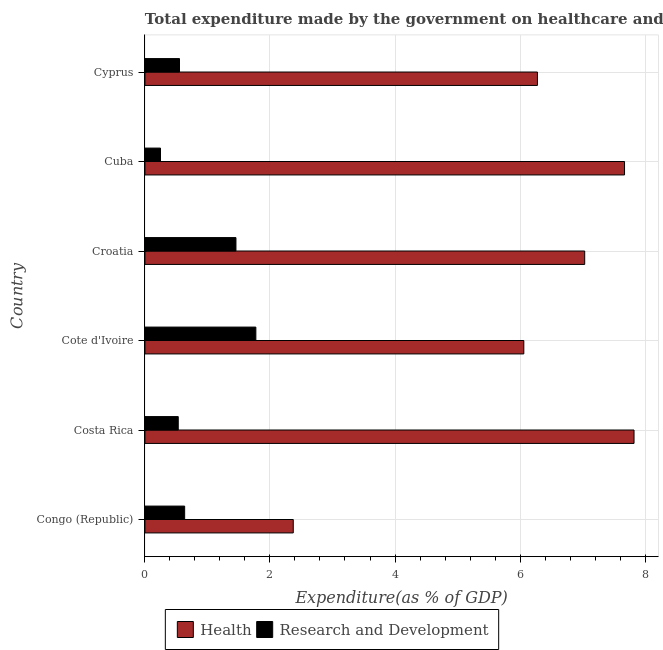How many groups of bars are there?
Give a very brief answer. 6. Are the number of bars per tick equal to the number of legend labels?
Ensure brevity in your answer.  Yes. Are the number of bars on each tick of the Y-axis equal?
Make the answer very short. Yes. How many bars are there on the 6th tick from the top?
Your answer should be very brief. 2. How many bars are there on the 1st tick from the bottom?
Keep it short and to the point. 2. What is the label of the 2nd group of bars from the top?
Offer a terse response. Cuba. What is the expenditure in r&d in Cuba?
Provide a short and direct response. 0.25. Across all countries, what is the maximum expenditure in healthcare?
Ensure brevity in your answer.  7.82. Across all countries, what is the minimum expenditure in healthcare?
Make the answer very short. 2.37. In which country was the expenditure in healthcare maximum?
Your answer should be very brief. Costa Rica. In which country was the expenditure in r&d minimum?
Provide a succinct answer. Cuba. What is the total expenditure in r&d in the graph?
Your answer should be very brief. 5.2. What is the difference between the expenditure in r&d in Cote d'Ivoire and that in Cuba?
Ensure brevity in your answer.  1.52. What is the difference between the expenditure in r&d in Costa Rica and the expenditure in healthcare in Congo (Republic)?
Keep it short and to the point. -1.84. What is the average expenditure in r&d per country?
Provide a succinct answer. 0.87. What is the difference between the expenditure in r&d and expenditure in healthcare in Croatia?
Make the answer very short. -5.58. In how many countries, is the expenditure in healthcare greater than 5.6 %?
Provide a short and direct response. 5. What is the ratio of the expenditure in r&d in Costa Rica to that in Cuba?
Offer a terse response. 2.14. Is the expenditure in healthcare in Cuba less than that in Cyprus?
Provide a succinct answer. No. Is the difference between the expenditure in r&d in Cote d'Ivoire and Cyprus greater than the difference between the expenditure in healthcare in Cote d'Ivoire and Cyprus?
Your answer should be compact. Yes. What is the difference between the highest and the second highest expenditure in healthcare?
Offer a very short reply. 0.15. What is the difference between the highest and the lowest expenditure in healthcare?
Provide a succinct answer. 5.45. In how many countries, is the expenditure in r&d greater than the average expenditure in r&d taken over all countries?
Make the answer very short. 2. What does the 2nd bar from the top in Cote d'Ivoire represents?
Your answer should be very brief. Health. What does the 1st bar from the bottom in Cote d'Ivoire represents?
Your answer should be compact. Health. What is the difference between two consecutive major ticks on the X-axis?
Ensure brevity in your answer.  2. Does the graph contain any zero values?
Keep it short and to the point. No. How many legend labels are there?
Give a very brief answer. 2. What is the title of the graph?
Your answer should be very brief. Total expenditure made by the government on healthcare and R&D projects in 2006. What is the label or title of the X-axis?
Make the answer very short. Expenditure(as % of GDP). What is the label or title of the Y-axis?
Offer a very short reply. Country. What is the Expenditure(as % of GDP) of Health in Congo (Republic)?
Keep it short and to the point. 2.37. What is the Expenditure(as % of GDP) in Research and Development in Congo (Republic)?
Your answer should be very brief. 0.64. What is the Expenditure(as % of GDP) in Health in Costa Rica?
Provide a succinct answer. 7.82. What is the Expenditure(as % of GDP) in Research and Development in Costa Rica?
Ensure brevity in your answer.  0.53. What is the Expenditure(as % of GDP) in Health in Cote d'Ivoire?
Your response must be concise. 6.06. What is the Expenditure(as % of GDP) of Research and Development in Cote d'Ivoire?
Provide a short and direct response. 1.77. What is the Expenditure(as % of GDP) of Health in Croatia?
Keep it short and to the point. 7.03. What is the Expenditure(as % of GDP) of Research and Development in Croatia?
Keep it short and to the point. 1.46. What is the Expenditure(as % of GDP) of Health in Cuba?
Your response must be concise. 7.67. What is the Expenditure(as % of GDP) in Research and Development in Cuba?
Your answer should be very brief. 0.25. What is the Expenditure(as % of GDP) of Health in Cyprus?
Provide a succinct answer. 6.28. What is the Expenditure(as % of GDP) in Research and Development in Cyprus?
Give a very brief answer. 0.55. Across all countries, what is the maximum Expenditure(as % of GDP) of Health?
Keep it short and to the point. 7.82. Across all countries, what is the maximum Expenditure(as % of GDP) in Research and Development?
Give a very brief answer. 1.77. Across all countries, what is the minimum Expenditure(as % of GDP) of Health?
Make the answer very short. 2.37. Across all countries, what is the minimum Expenditure(as % of GDP) of Research and Development?
Give a very brief answer. 0.25. What is the total Expenditure(as % of GDP) in Health in the graph?
Give a very brief answer. 37.24. What is the total Expenditure(as % of GDP) in Research and Development in the graph?
Provide a short and direct response. 5.2. What is the difference between the Expenditure(as % of GDP) in Health in Congo (Republic) and that in Costa Rica?
Make the answer very short. -5.45. What is the difference between the Expenditure(as % of GDP) of Research and Development in Congo (Republic) and that in Costa Rica?
Offer a very short reply. 0.1. What is the difference between the Expenditure(as % of GDP) in Health in Congo (Republic) and that in Cote d'Ivoire?
Provide a short and direct response. -3.69. What is the difference between the Expenditure(as % of GDP) of Research and Development in Congo (Republic) and that in Cote d'Ivoire?
Provide a succinct answer. -1.14. What is the difference between the Expenditure(as % of GDP) in Health in Congo (Republic) and that in Croatia?
Ensure brevity in your answer.  -4.66. What is the difference between the Expenditure(as % of GDP) of Research and Development in Congo (Republic) and that in Croatia?
Your answer should be very brief. -0.82. What is the difference between the Expenditure(as % of GDP) in Health in Congo (Republic) and that in Cuba?
Make the answer very short. -5.3. What is the difference between the Expenditure(as % of GDP) of Research and Development in Congo (Republic) and that in Cuba?
Offer a terse response. 0.39. What is the difference between the Expenditure(as % of GDP) of Health in Congo (Republic) and that in Cyprus?
Provide a succinct answer. -3.91. What is the difference between the Expenditure(as % of GDP) in Research and Development in Congo (Republic) and that in Cyprus?
Provide a succinct answer. 0.08. What is the difference between the Expenditure(as % of GDP) of Health in Costa Rica and that in Cote d'Ivoire?
Provide a succinct answer. 1.76. What is the difference between the Expenditure(as % of GDP) of Research and Development in Costa Rica and that in Cote d'Ivoire?
Give a very brief answer. -1.24. What is the difference between the Expenditure(as % of GDP) in Health in Costa Rica and that in Croatia?
Ensure brevity in your answer.  0.79. What is the difference between the Expenditure(as % of GDP) in Research and Development in Costa Rica and that in Croatia?
Ensure brevity in your answer.  -0.92. What is the difference between the Expenditure(as % of GDP) in Health in Costa Rica and that in Cuba?
Make the answer very short. 0.15. What is the difference between the Expenditure(as % of GDP) of Research and Development in Costa Rica and that in Cuba?
Make the answer very short. 0.28. What is the difference between the Expenditure(as % of GDP) of Health in Costa Rica and that in Cyprus?
Provide a succinct answer. 1.55. What is the difference between the Expenditure(as % of GDP) of Research and Development in Costa Rica and that in Cyprus?
Ensure brevity in your answer.  -0.02. What is the difference between the Expenditure(as % of GDP) of Health in Cote d'Ivoire and that in Croatia?
Offer a very short reply. -0.97. What is the difference between the Expenditure(as % of GDP) in Research and Development in Cote d'Ivoire and that in Croatia?
Your answer should be compact. 0.32. What is the difference between the Expenditure(as % of GDP) in Health in Cote d'Ivoire and that in Cuba?
Your answer should be very brief. -1.61. What is the difference between the Expenditure(as % of GDP) of Research and Development in Cote d'Ivoire and that in Cuba?
Keep it short and to the point. 1.53. What is the difference between the Expenditure(as % of GDP) of Health in Cote d'Ivoire and that in Cyprus?
Your response must be concise. -0.22. What is the difference between the Expenditure(as % of GDP) of Research and Development in Cote d'Ivoire and that in Cyprus?
Your answer should be very brief. 1.22. What is the difference between the Expenditure(as % of GDP) in Health in Croatia and that in Cuba?
Offer a very short reply. -0.64. What is the difference between the Expenditure(as % of GDP) in Research and Development in Croatia and that in Cuba?
Provide a short and direct response. 1.21. What is the difference between the Expenditure(as % of GDP) in Health in Croatia and that in Cyprus?
Make the answer very short. 0.76. What is the difference between the Expenditure(as % of GDP) in Research and Development in Croatia and that in Cyprus?
Make the answer very short. 0.9. What is the difference between the Expenditure(as % of GDP) of Health in Cuba and that in Cyprus?
Your response must be concise. 1.39. What is the difference between the Expenditure(as % of GDP) in Research and Development in Cuba and that in Cyprus?
Give a very brief answer. -0.3. What is the difference between the Expenditure(as % of GDP) in Health in Congo (Republic) and the Expenditure(as % of GDP) in Research and Development in Costa Rica?
Keep it short and to the point. 1.84. What is the difference between the Expenditure(as % of GDP) of Health in Congo (Republic) and the Expenditure(as % of GDP) of Research and Development in Cote d'Ivoire?
Offer a terse response. 0.6. What is the difference between the Expenditure(as % of GDP) of Health in Congo (Republic) and the Expenditure(as % of GDP) of Research and Development in Cuba?
Keep it short and to the point. 2.12. What is the difference between the Expenditure(as % of GDP) of Health in Congo (Republic) and the Expenditure(as % of GDP) of Research and Development in Cyprus?
Your response must be concise. 1.82. What is the difference between the Expenditure(as % of GDP) of Health in Costa Rica and the Expenditure(as % of GDP) of Research and Development in Cote d'Ivoire?
Your response must be concise. 6.05. What is the difference between the Expenditure(as % of GDP) in Health in Costa Rica and the Expenditure(as % of GDP) in Research and Development in Croatia?
Your answer should be very brief. 6.37. What is the difference between the Expenditure(as % of GDP) in Health in Costa Rica and the Expenditure(as % of GDP) in Research and Development in Cuba?
Give a very brief answer. 7.57. What is the difference between the Expenditure(as % of GDP) in Health in Costa Rica and the Expenditure(as % of GDP) in Research and Development in Cyprus?
Your answer should be compact. 7.27. What is the difference between the Expenditure(as % of GDP) in Health in Cote d'Ivoire and the Expenditure(as % of GDP) in Research and Development in Croatia?
Offer a terse response. 4.6. What is the difference between the Expenditure(as % of GDP) in Health in Cote d'Ivoire and the Expenditure(as % of GDP) in Research and Development in Cuba?
Your answer should be very brief. 5.81. What is the difference between the Expenditure(as % of GDP) of Health in Cote d'Ivoire and the Expenditure(as % of GDP) of Research and Development in Cyprus?
Offer a very short reply. 5.51. What is the difference between the Expenditure(as % of GDP) of Health in Croatia and the Expenditure(as % of GDP) of Research and Development in Cuba?
Ensure brevity in your answer.  6.79. What is the difference between the Expenditure(as % of GDP) in Health in Croatia and the Expenditure(as % of GDP) in Research and Development in Cyprus?
Keep it short and to the point. 6.48. What is the difference between the Expenditure(as % of GDP) of Health in Cuba and the Expenditure(as % of GDP) of Research and Development in Cyprus?
Offer a terse response. 7.12. What is the average Expenditure(as % of GDP) in Health per country?
Provide a short and direct response. 6.21. What is the average Expenditure(as % of GDP) in Research and Development per country?
Keep it short and to the point. 0.87. What is the difference between the Expenditure(as % of GDP) in Health and Expenditure(as % of GDP) in Research and Development in Congo (Republic)?
Offer a terse response. 1.74. What is the difference between the Expenditure(as % of GDP) of Health and Expenditure(as % of GDP) of Research and Development in Costa Rica?
Offer a very short reply. 7.29. What is the difference between the Expenditure(as % of GDP) of Health and Expenditure(as % of GDP) of Research and Development in Cote d'Ivoire?
Your answer should be compact. 4.29. What is the difference between the Expenditure(as % of GDP) of Health and Expenditure(as % of GDP) of Research and Development in Croatia?
Your response must be concise. 5.58. What is the difference between the Expenditure(as % of GDP) in Health and Expenditure(as % of GDP) in Research and Development in Cuba?
Ensure brevity in your answer.  7.42. What is the difference between the Expenditure(as % of GDP) in Health and Expenditure(as % of GDP) in Research and Development in Cyprus?
Provide a short and direct response. 5.72. What is the ratio of the Expenditure(as % of GDP) of Health in Congo (Republic) to that in Costa Rica?
Provide a short and direct response. 0.3. What is the ratio of the Expenditure(as % of GDP) of Research and Development in Congo (Republic) to that in Costa Rica?
Ensure brevity in your answer.  1.19. What is the ratio of the Expenditure(as % of GDP) in Health in Congo (Republic) to that in Cote d'Ivoire?
Offer a very short reply. 0.39. What is the ratio of the Expenditure(as % of GDP) of Research and Development in Congo (Republic) to that in Cote d'Ivoire?
Your response must be concise. 0.36. What is the ratio of the Expenditure(as % of GDP) of Health in Congo (Republic) to that in Croatia?
Your response must be concise. 0.34. What is the ratio of the Expenditure(as % of GDP) in Research and Development in Congo (Republic) to that in Croatia?
Provide a short and direct response. 0.44. What is the ratio of the Expenditure(as % of GDP) of Health in Congo (Republic) to that in Cuba?
Offer a terse response. 0.31. What is the ratio of the Expenditure(as % of GDP) of Research and Development in Congo (Republic) to that in Cuba?
Give a very brief answer. 2.55. What is the ratio of the Expenditure(as % of GDP) in Health in Congo (Republic) to that in Cyprus?
Your answer should be very brief. 0.38. What is the ratio of the Expenditure(as % of GDP) of Research and Development in Congo (Republic) to that in Cyprus?
Make the answer very short. 1.15. What is the ratio of the Expenditure(as % of GDP) in Health in Costa Rica to that in Cote d'Ivoire?
Provide a short and direct response. 1.29. What is the ratio of the Expenditure(as % of GDP) of Research and Development in Costa Rica to that in Cote d'Ivoire?
Your answer should be very brief. 0.3. What is the ratio of the Expenditure(as % of GDP) of Health in Costa Rica to that in Croatia?
Provide a short and direct response. 1.11. What is the ratio of the Expenditure(as % of GDP) in Research and Development in Costa Rica to that in Croatia?
Keep it short and to the point. 0.37. What is the ratio of the Expenditure(as % of GDP) in Health in Costa Rica to that in Cuba?
Provide a short and direct response. 1.02. What is the ratio of the Expenditure(as % of GDP) of Research and Development in Costa Rica to that in Cuba?
Your answer should be compact. 2.14. What is the ratio of the Expenditure(as % of GDP) in Health in Costa Rica to that in Cyprus?
Your response must be concise. 1.25. What is the ratio of the Expenditure(as % of GDP) in Research and Development in Costa Rica to that in Cyprus?
Ensure brevity in your answer.  0.96. What is the ratio of the Expenditure(as % of GDP) in Health in Cote d'Ivoire to that in Croatia?
Provide a succinct answer. 0.86. What is the ratio of the Expenditure(as % of GDP) in Research and Development in Cote d'Ivoire to that in Croatia?
Offer a very short reply. 1.22. What is the ratio of the Expenditure(as % of GDP) of Health in Cote d'Ivoire to that in Cuba?
Make the answer very short. 0.79. What is the ratio of the Expenditure(as % of GDP) in Research and Development in Cote d'Ivoire to that in Cuba?
Offer a very short reply. 7.12. What is the ratio of the Expenditure(as % of GDP) of Health in Cote d'Ivoire to that in Cyprus?
Provide a short and direct response. 0.97. What is the ratio of the Expenditure(as % of GDP) of Research and Development in Cote d'Ivoire to that in Cyprus?
Provide a short and direct response. 3.21. What is the ratio of the Expenditure(as % of GDP) of Health in Croatia to that in Cuba?
Provide a short and direct response. 0.92. What is the ratio of the Expenditure(as % of GDP) in Research and Development in Croatia to that in Cuba?
Your answer should be compact. 5.84. What is the ratio of the Expenditure(as % of GDP) of Health in Croatia to that in Cyprus?
Give a very brief answer. 1.12. What is the ratio of the Expenditure(as % of GDP) of Research and Development in Croatia to that in Cyprus?
Your answer should be compact. 2.63. What is the ratio of the Expenditure(as % of GDP) of Health in Cuba to that in Cyprus?
Provide a succinct answer. 1.22. What is the ratio of the Expenditure(as % of GDP) in Research and Development in Cuba to that in Cyprus?
Keep it short and to the point. 0.45. What is the difference between the highest and the second highest Expenditure(as % of GDP) of Health?
Provide a succinct answer. 0.15. What is the difference between the highest and the second highest Expenditure(as % of GDP) in Research and Development?
Your answer should be compact. 0.32. What is the difference between the highest and the lowest Expenditure(as % of GDP) of Health?
Provide a succinct answer. 5.45. What is the difference between the highest and the lowest Expenditure(as % of GDP) in Research and Development?
Your response must be concise. 1.53. 